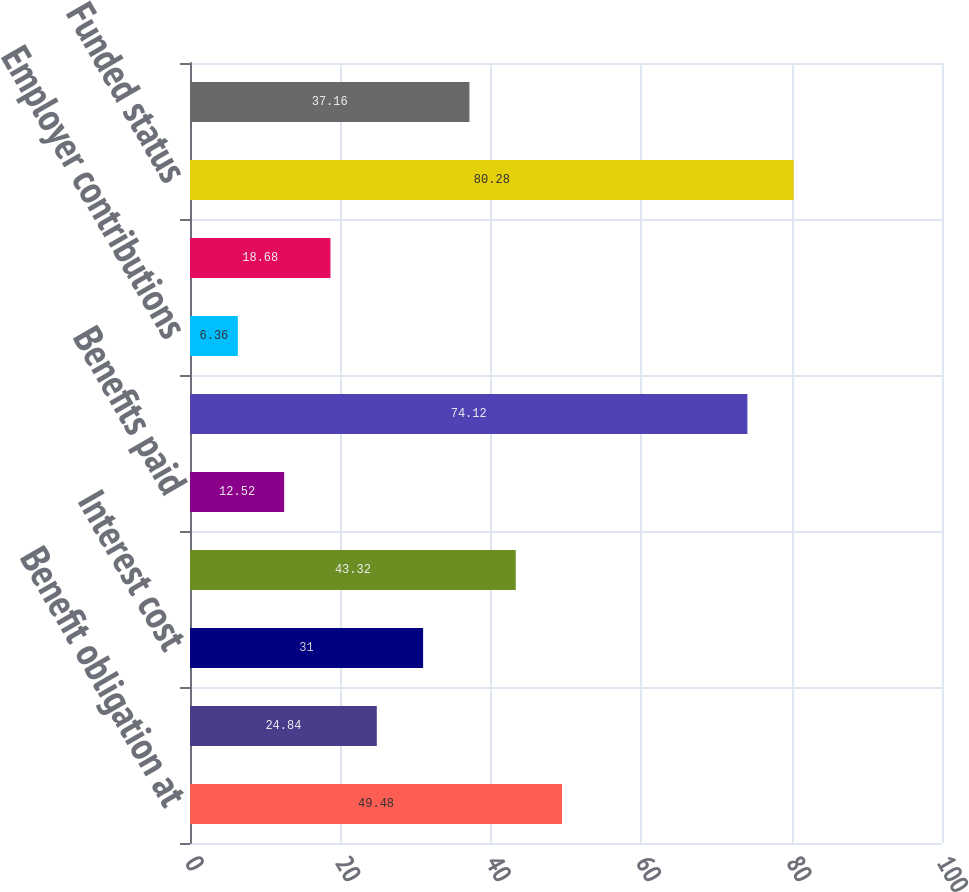<chart> <loc_0><loc_0><loc_500><loc_500><bar_chart><fcel>Benefit obligation at<fcel>Service cost<fcel>Interest cost<fcel>Actuarial loss (gain)<fcel>Benefits paid<fcel>Benefit obligation at end of<fcel>Employer contributions<fcel>Benefits paid from plan assets<fcel>Funded status<fcel>Unrecognized net actuarial<nl><fcel>49.48<fcel>24.84<fcel>31<fcel>43.32<fcel>12.52<fcel>74.12<fcel>6.36<fcel>18.68<fcel>80.28<fcel>37.16<nl></chart> 